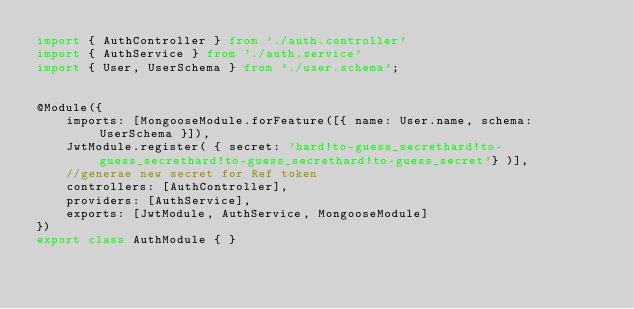Convert code to text. <code><loc_0><loc_0><loc_500><loc_500><_TypeScript_>import { AuthController } from './auth.controller'
import { AuthService } from './auth.service'
import { User, UserSchema } from './user.schema';


@Module({
    imports: [MongooseModule.forFeature([{ name: User.name, schema: UserSchema }]),
    JwtModule.register( { secret: 'hard!to-guess_secrethard!to-guess_secrethard!to-guess_secrethard!to-guess_secret'} )],
    //generae new secret for Ref token
    controllers: [AuthController],
    providers: [AuthService],
    exports: [JwtModule, AuthService, MongooseModule]
})
export class AuthModule { }</code> 